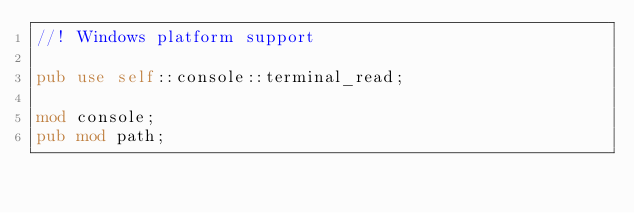Convert code to text. <code><loc_0><loc_0><loc_500><loc_500><_Rust_>//! Windows platform support

pub use self::console::terminal_read;

mod console;
pub mod path;
</code> 